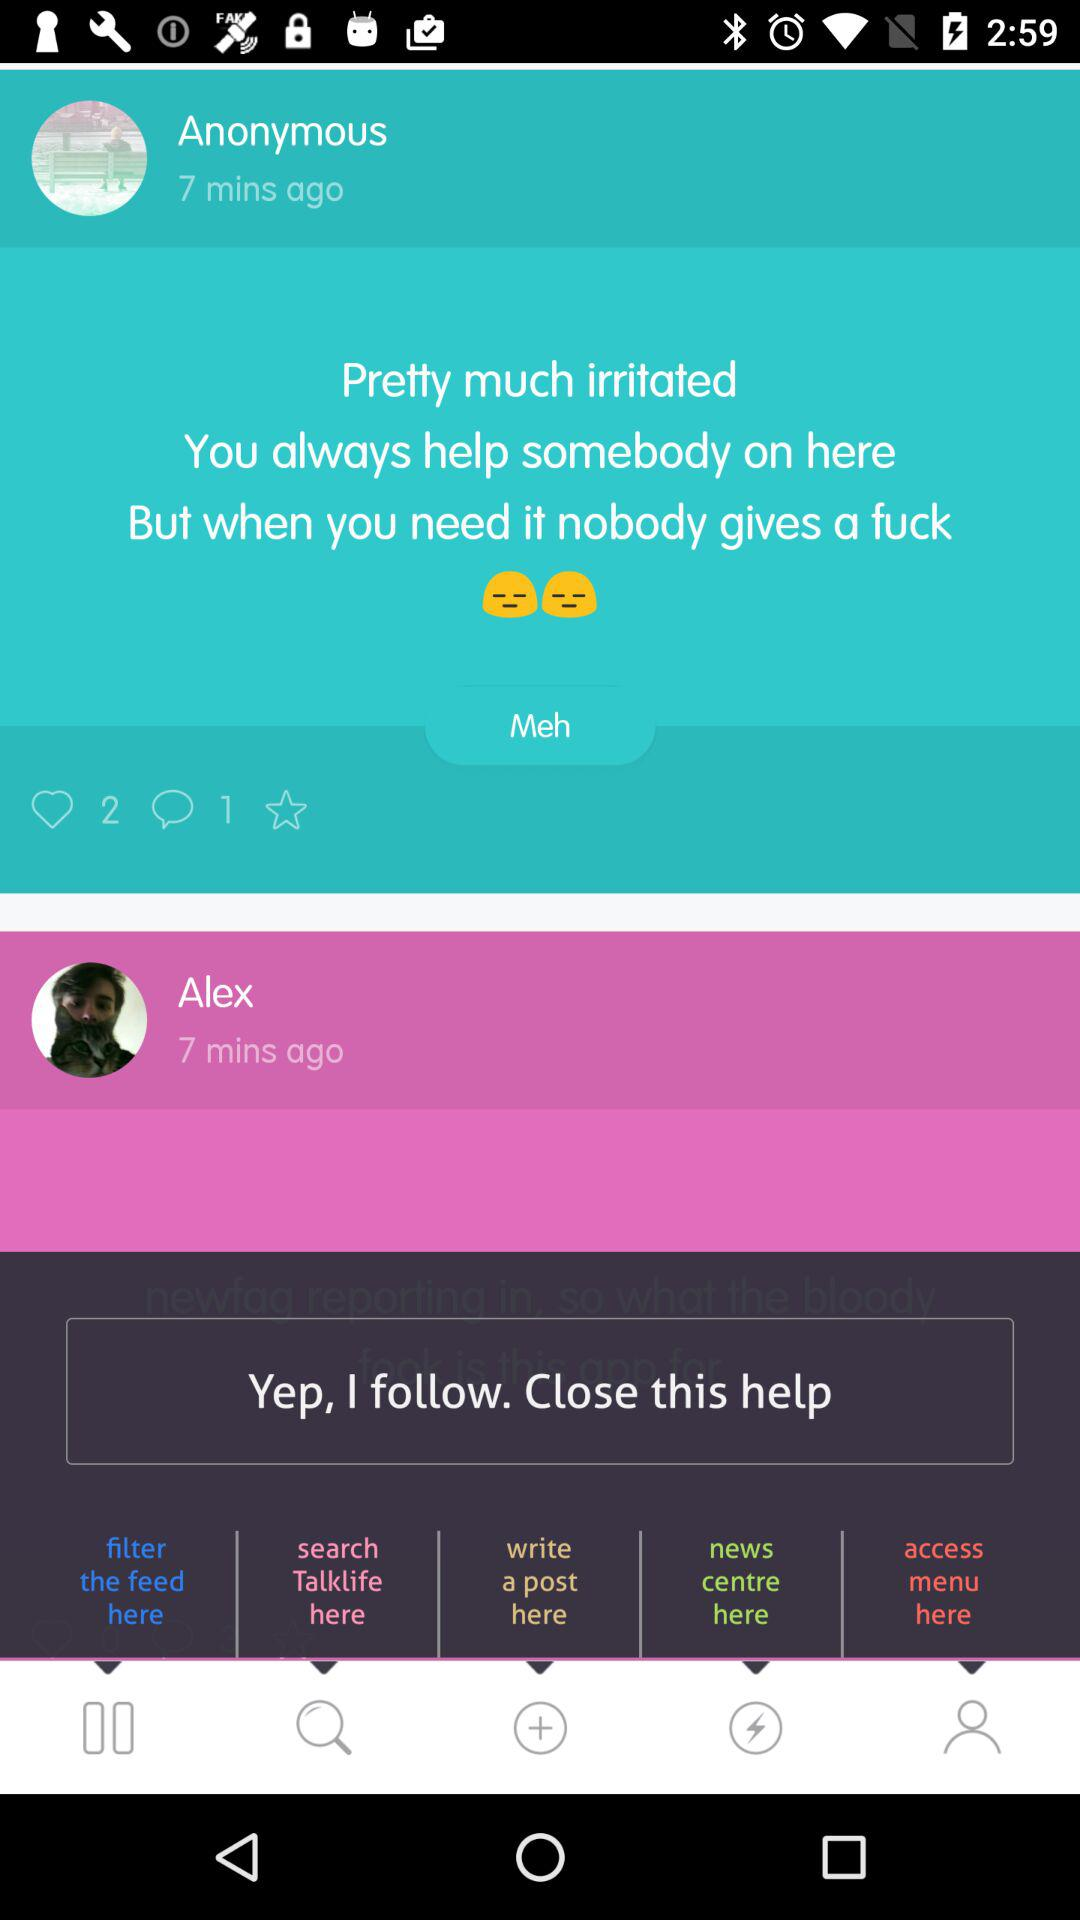How many sad faces are there in the post?
Answer the question using a single word or phrase. 2 